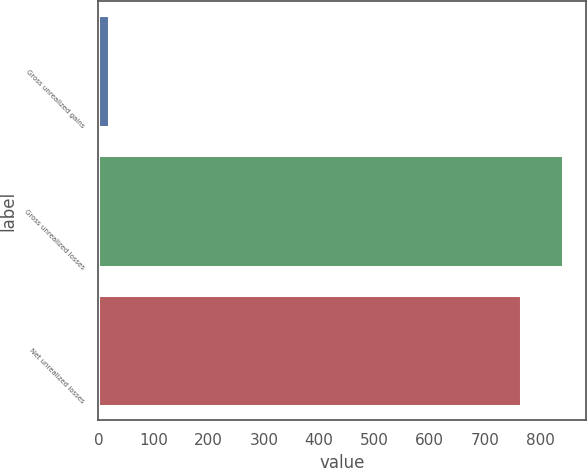Convert chart. <chart><loc_0><loc_0><loc_500><loc_500><bar_chart><fcel>Gross unrealized gains<fcel>Gross unrealized losses<fcel>Net unrealized losses<nl><fcel>20<fcel>841.5<fcel>765<nl></chart> 